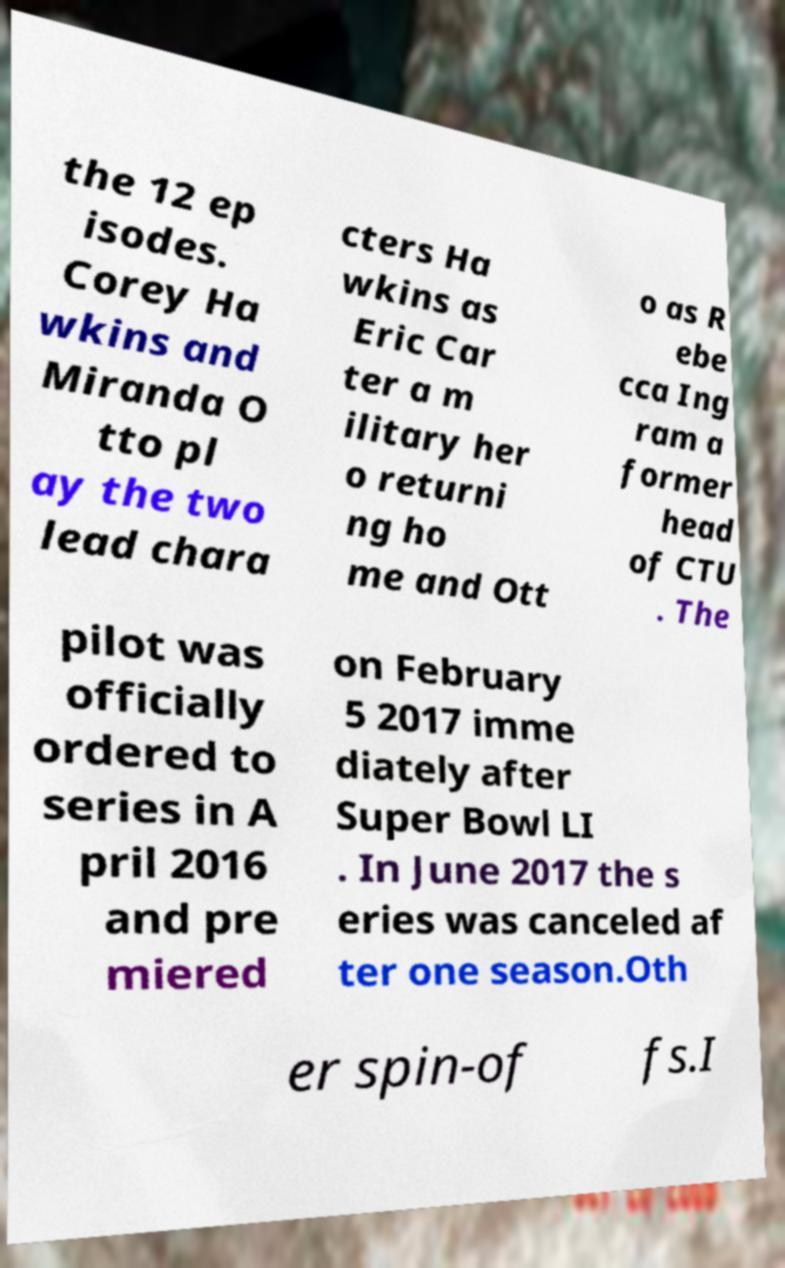What messages or text are displayed in this image? I need them in a readable, typed format. the 12 ep isodes. Corey Ha wkins and Miranda O tto pl ay the two lead chara cters Ha wkins as Eric Car ter a m ilitary her o returni ng ho me and Ott o as R ebe cca Ing ram a former head of CTU . The pilot was officially ordered to series in A pril 2016 and pre miered on February 5 2017 imme diately after Super Bowl LI . In June 2017 the s eries was canceled af ter one season.Oth er spin-of fs.I 